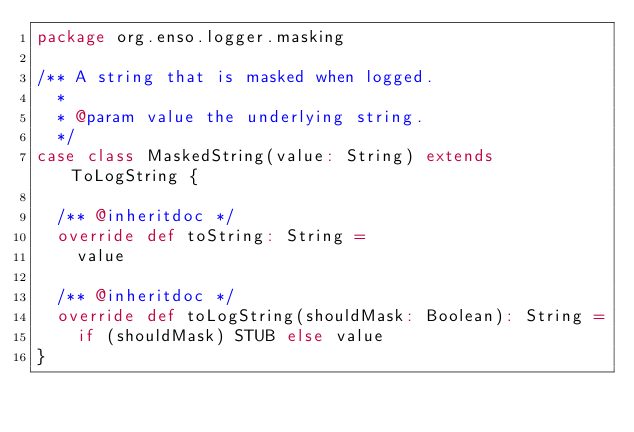<code> <loc_0><loc_0><loc_500><loc_500><_Scala_>package org.enso.logger.masking

/** A string that is masked when logged.
  *
  * @param value the underlying string.
  */
case class MaskedString(value: String) extends ToLogString {

  /** @inheritdoc */
  override def toString: String =
    value

  /** @inheritdoc */
  override def toLogString(shouldMask: Boolean): String =
    if (shouldMask) STUB else value
}
</code> 